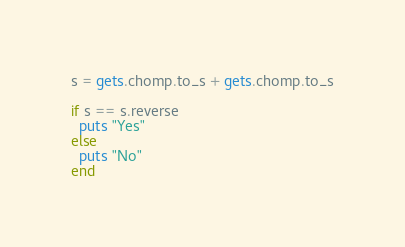Convert code to text. <code><loc_0><loc_0><loc_500><loc_500><_Ruby_>s = gets.chomp.to_s + gets.chomp.to_s

if s == s.reverse
  puts "Yes"
else
  puts "No"
end</code> 